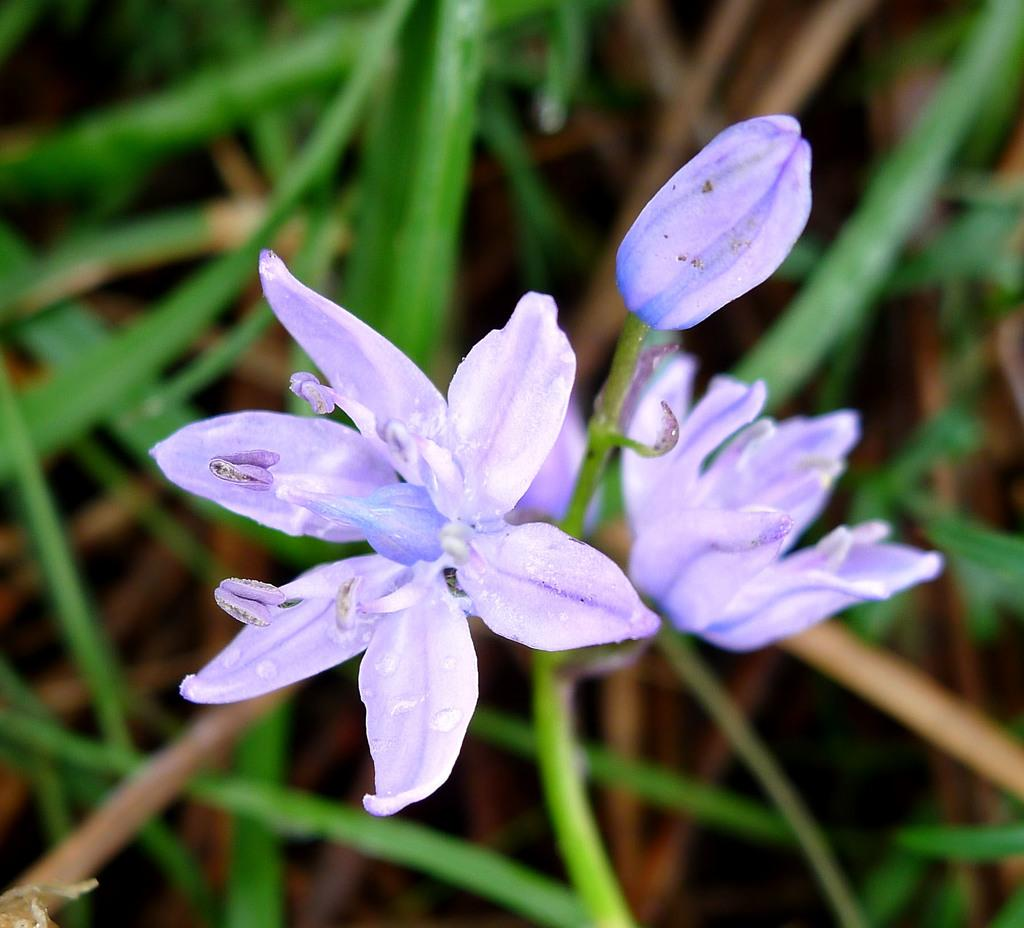What is the main subject in the center of the image? There are flowers in the center of the image. What can be seen in the background of the image? Leaves are present in the background of the image. What type of boot is visible in the image? There is no boot present in the image; it features flowers and leaves. Can you describe the plane that is flying in the image? There is no plane present in the image; it only contains flowers and leaves. 